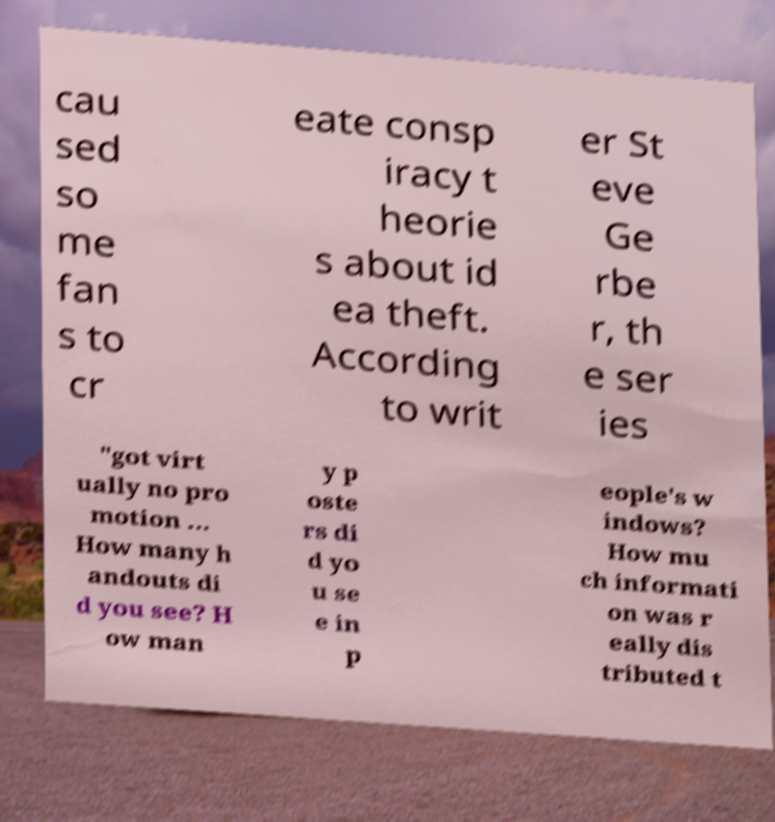Could you assist in decoding the text presented in this image and type it out clearly? cau sed so me fan s to cr eate consp iracy t heorie s about id ea theft. According to writ er St eve Ge rbe r, th e ser ies "got virt ually no pro motion ... How many h andouts di d you see? H ow man y p oste rs di d yo u se e in p eople's w indows? How mu ch informati on was r eally dis tributed t 